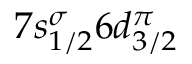Convert formula to latex. <formula><loc_0><loc_0><loc_500><loc_500>7 s _ { 1 / 2 } ^ { \sigma } 6 d _ { 3 / 2 } ^ { \pi }</formula> 